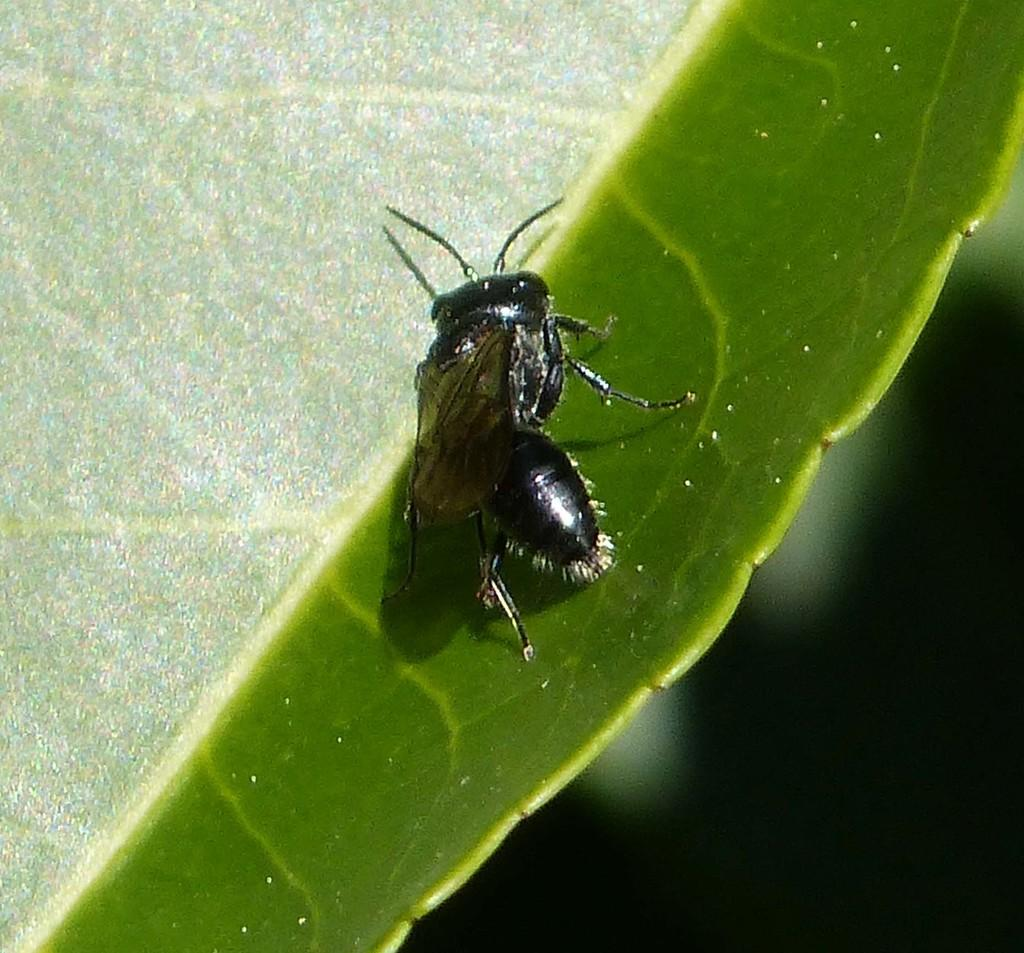What is present on the leaf in the image? There is an insect on a leaf in the image. Where is the insect located in relation to the image? The insect is located in the center of the image. What type of bear can be seen in the image? There is no bear present in the image; it features an insect on a leaf. What season is depicted in the image? The image does not depict a specific season, as there are no seasonal cues present. 